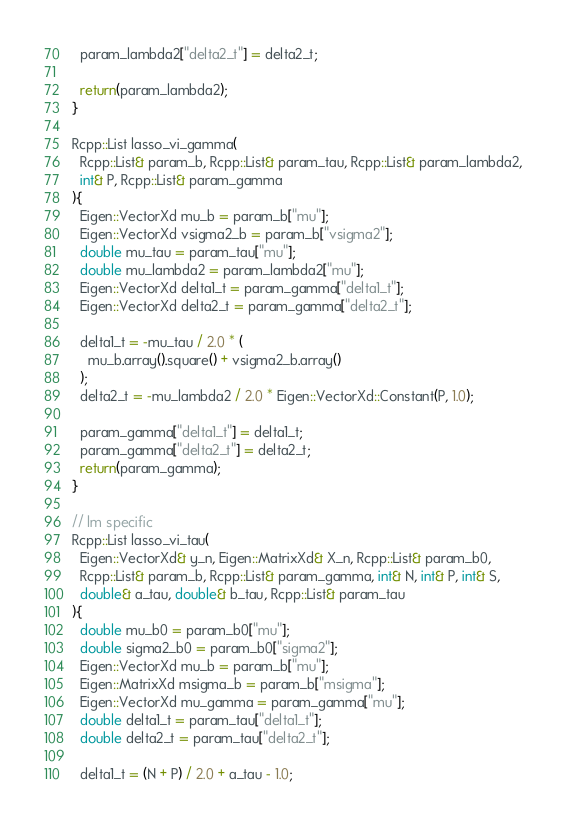Convert code to text. <code><loc_0><loc_0><loc_500><loc_500><_C++_>  param_lambda2["delta2_t"] = delta2_t;

  return(param_lambda2);
}

Rcpp::List lasso_vi_gamma(
  Rcpp::List& param_b, Rcpp::List& param_tau, Rcpp::List& param_lambda2,
  int& P, Rcpp::List& param_gamma
){
  Eigen::VectorXd mu_b = param_b["mu"];
  Eigen::VectorXd vsigma2_b = param_b["vsigma2"];
  double mu_tau = param_tau["mu"];
  double mu_lambda2 = param_lambda2["mu"];
  Eigen::VectorXd delta1_t = param_gamma["delta1_t"];
  Eigen::VectorXd delta2_t = param_gamma["delta2_t"];

  delta1_t = -mu_tau / 2.0 * (
    mu_b.array().square() + vsigma2_b.array()
  );
  delta2_t = -mu_lambda2 / 2.0 * Eigen::VectorXd::Constant(P, 1.0);

  param_gamma["delta1_t"] = delta1_t;
  param_gamma["delta2_t"] = delta2_t;
  return(param_gamma);
}

// lm specific
Rcpp::List lasso_vi_tau(
  Eigen::VectorXd& y_n, Eigen::MatrixXd& X_n, Rcpp::List& param_b0,
  Rcpp::List& param_b, Rcpp::List& param_gamma, int& N, int& P, int& S,
  double& a_tau, double& b_tau, Rcpp::List& param_tau
){
  double mu_b0 = param_b0["mu"];
  double sigma2_b0 = param_b0["sigma2"];
  Eigen::VectorXd mu_b = param_b["mu"];
  Eigen::MatrixXd msigma_b = param_b["msigma"];
  Eigen::VectorXd mu_gamma = param_gamma["mu"];
  double delta1_t = param_tau["delta1_t"];
  double delta2_t = param_tau["delta2_t"];

  delta1_t = (N + P) / 2.0 + a_tau - 1.0;</code> 